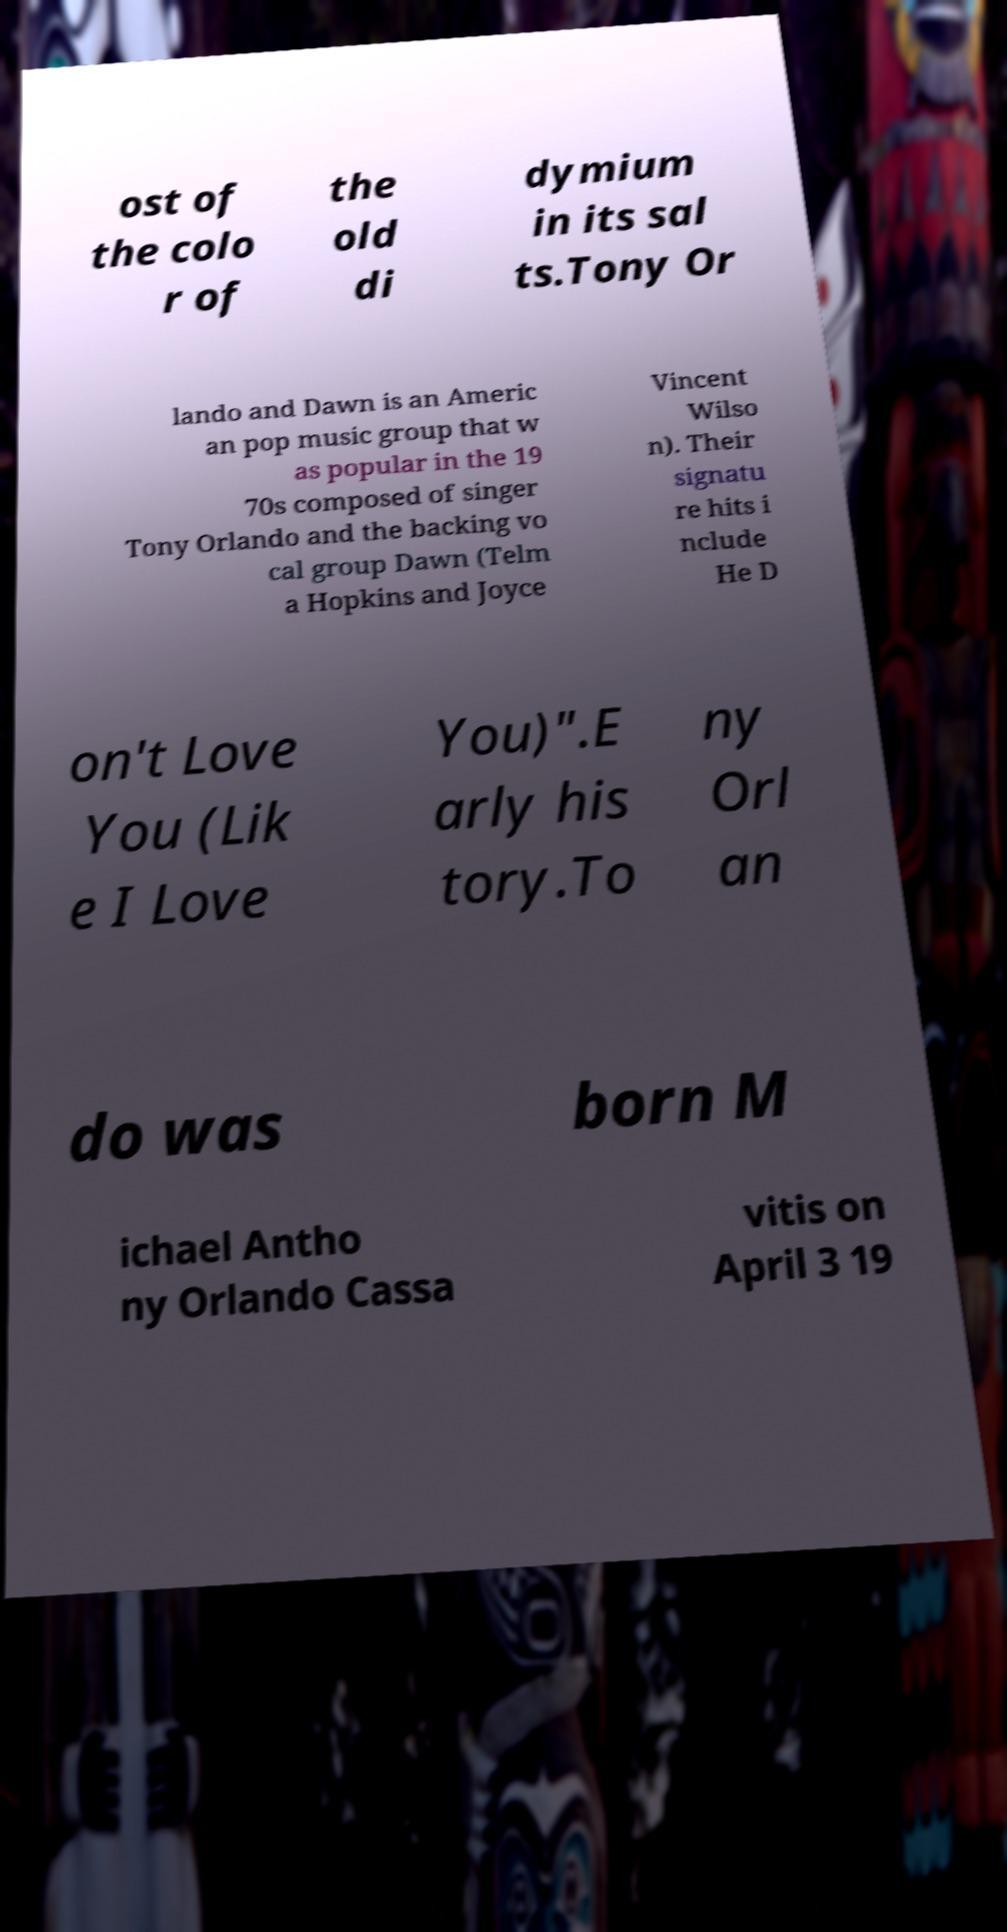I need the written content from this picture converted into text. Can you do that? ost of the colo r of the old di dymium in its sal ts.Tony Or lando and Dawn is an Americ an pop music group that w as popular in the 19 70s composed of singer Tony Orlando and the backing vo cal group Dawn (Telm a Hopkins and Joyce Vincent Wilso n). Their signatu re hits i nclude He D on't Love You (Lik e I Love You)".E arly his tory.To ny Orl an do was born M ichael Antho ny Orlando Cassa vitis on April 3 19 